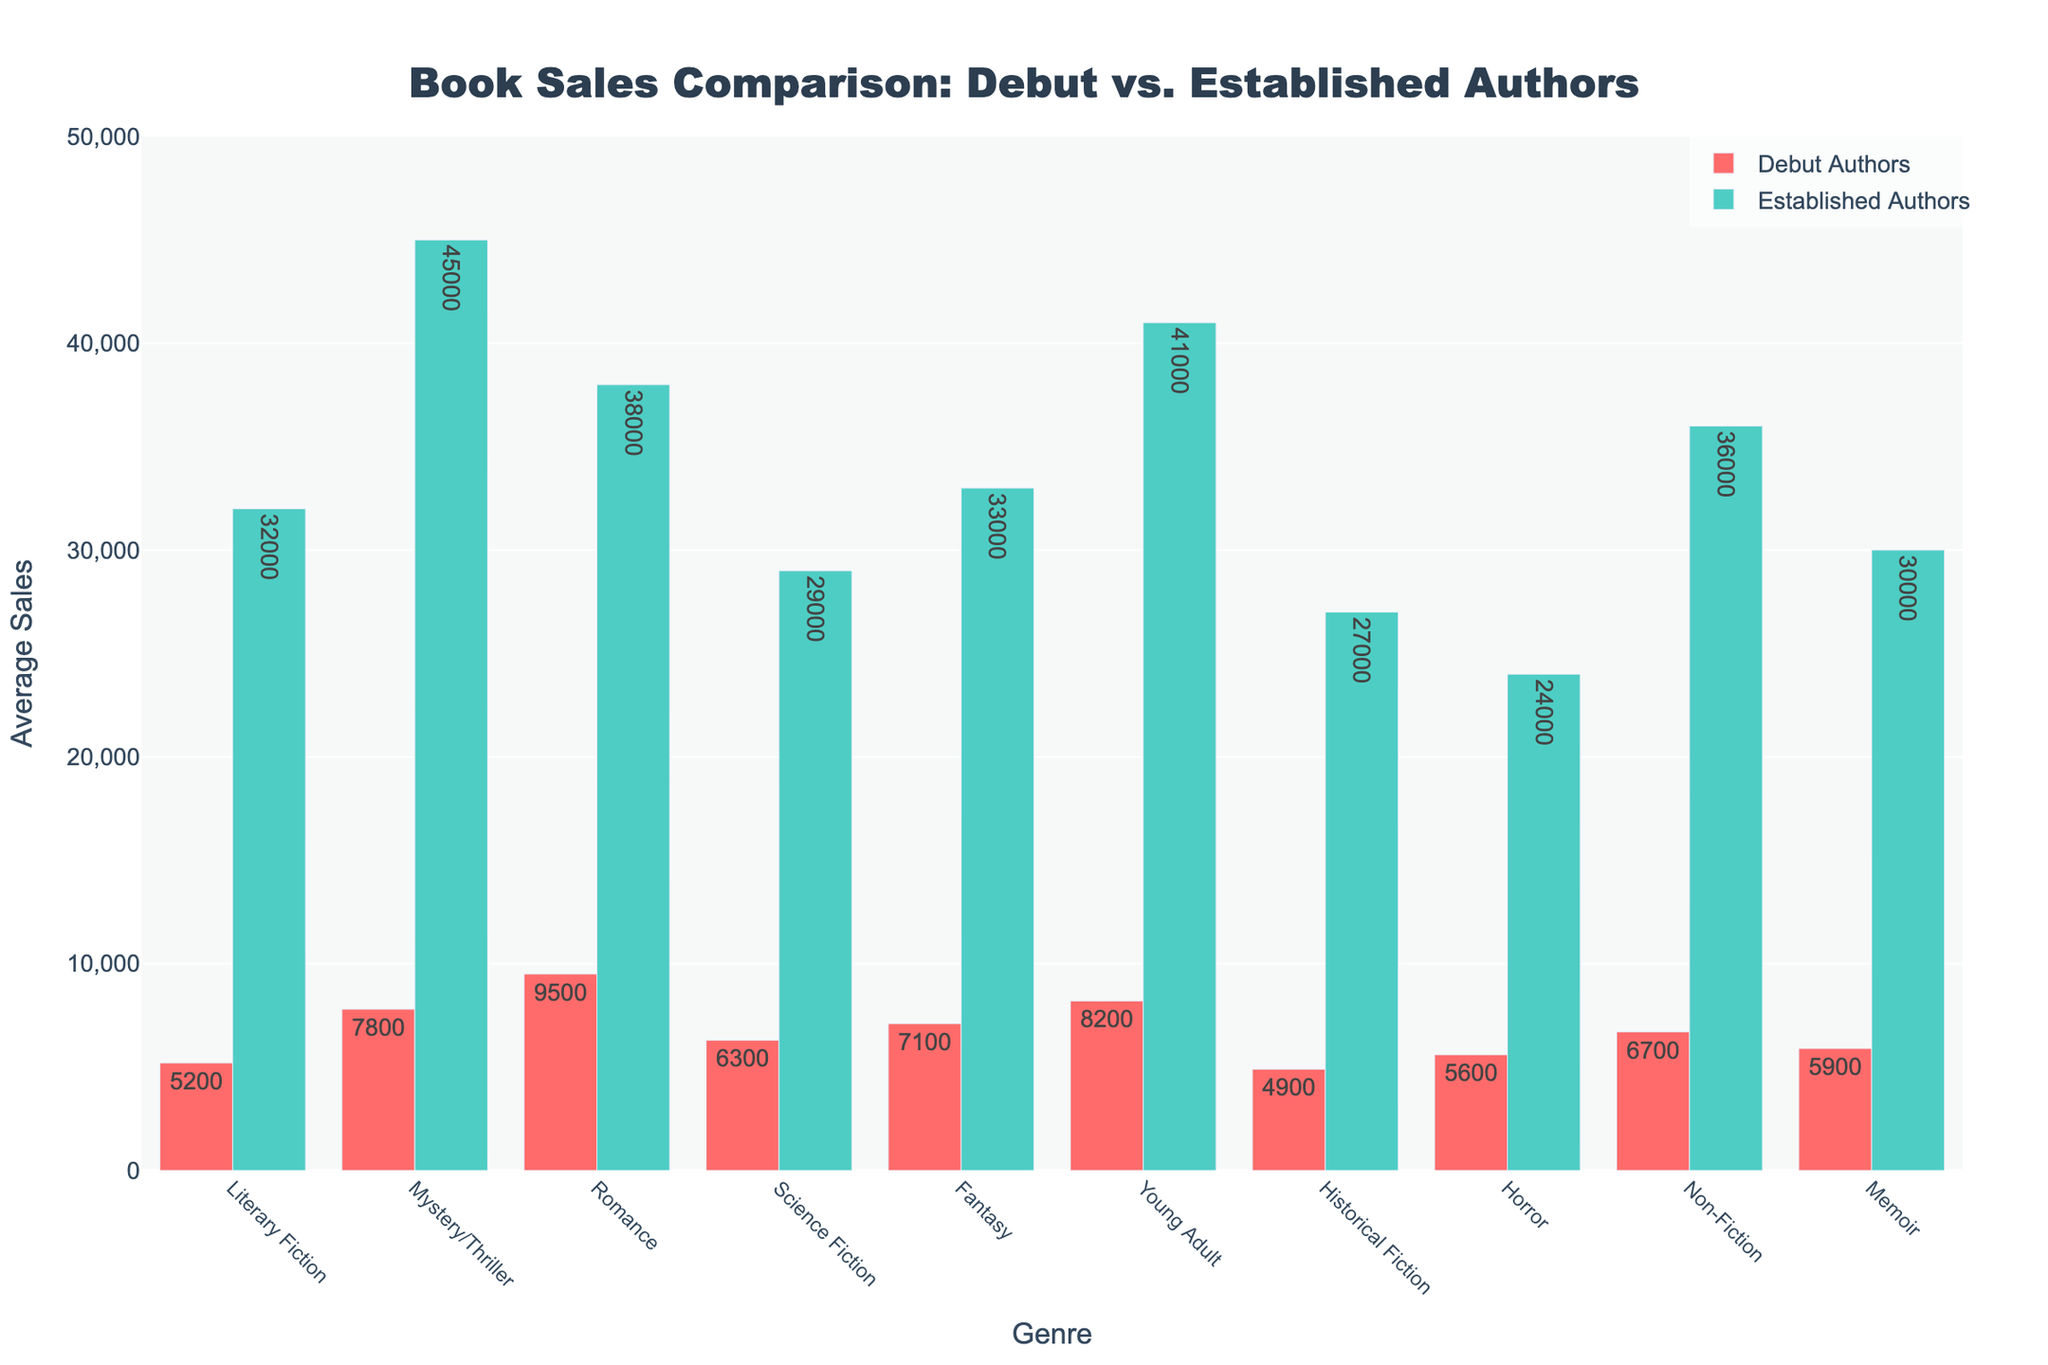What genre shows the largest difference in average sales between debut authors and established authors? Look at the differences in average sales for each genre. Romance has the largest difference: 38000 - 9500 = 28500.
Answer: Romance Which genre has the smallest average sales for debut authors? Compare the average sales for debut authors across all genres. Literary Fiction has the smallest average, which is 5200.
Answer: Literary Fiction How do the average sales of Horror for debut authors compare to those for Memoir? Compare the average sales of Horror (5600) and Memoir (5900) for debut authors. 5600 is less than 5900.
Answer: Horror has fewer average sales Which genre has the closest average sales between debut and established authors? Calculate the differences between debut and established authors for each genre. Literary Fiction has the smallest difference: 32000 - 5200 = 26800.
Answer: Literary Fiction Which genre has the highest average sales for established authors? Identify the maximum value for established authors' average sales across all genres. Mystery/Thriller has the highest with 45000.
Answer: Mystery/Thriller What is the summed average sales for debut authors in Romance, Science Fiction, and Fantasy? Add the average sales for debut authors in Romance (9500), Science Fiction (6300), and Fantasy (7100): 9500 + 6300 + 7100 = 22900.
Answer: 22900 How much higher are the average sales for Young Adult by established authors compared to debut authors? Subtract the average sales for debut authors from established authors for Young Adult: 41000 - 8200 = 32800.
Answer: 32800 Which genres have higher average sales for debut authors compared to Literary Fiction by established authors? Compare debut authors' average sales in each genre to the established authors' average sales in Literary Fiction (32000). No debut authors in any genre exceed 32000.
Answer: None What is the average difference in sales between established and debut authors across all genres? Calculate the difference for each genre and then find the average difference:
(32000-5200 + 45000-7800 + 38000-9500 + 29000-6300 + 33000-7100 + 41000-8200 + 27000-4900 + 24000-5600 + 36000-6700 + 30000-5900)/10 = 25000.
Answer: 25000 How does the average sales of Non-Fiction for debut authors compare to Literary Fiction for established authors? Compare the average sales of debut authors in Non-Fiction (6700) to established authors in Literary Fiction (32000). 6700 is less than 32000.
Answer: Non-Fiction has fewer average sales 